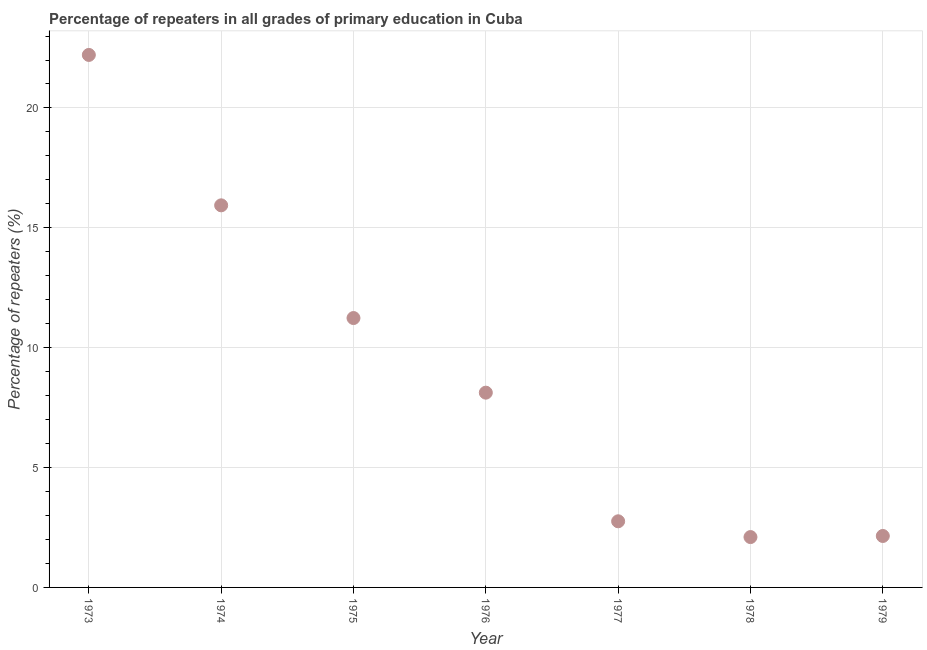What is the percentage of repeaters in primary education in 1973?
Make the answer very short. 22.21. Across all years, what is the maximum percentage of repeaters in primary education?
Make the answer very short. 22.21. Across all years, what is the minimum percentage of repeaters in primary education?
Make the answer very short. 2.1. In which year was the percentage of repeaters in primary education maximum?
Ensure brevity in your answer.  1973. In which year was the percentage of repeaters in primary education minimum?
Offer a terse response. 1978. What is the sum of the percentage of repeaters in primary education?
Keep it short and to the point. 64.52. What is the difference between the percentage of repeaters in primary education in 1975 and 1979?
Offer a very short reply. 9.09. What is the average percentage of repeaters in primary education per year?
Your answer should be very brief. 9.22. What is the median percentage of repeaters in primary education?
Offer a very short reply. 8.12. What is the ratio of the percentage of repeaters in primary education in 1973 to that in 1979?
Offer a very short reply. 10.35. Is the difference between the percentage of repeaters in primary education in 1973 and 1977 greater than the difference between any two years?
Make the answer very short. No. What is the difference between the highest and the second highest percentage of repeaters in primary education?
Keep it short and to the point. 6.27. Is the sum of the percentage of repeaters in primary education in 1973 and 1977 greater than the maximum percentage of repeaters in primary education across all years?
Make the answer very short. Yes. What is the difference between the highest and the lowest percentage of repeaters in primary education?
Your answer should be very brief. 20.11. Does the percentage of repeaters in primary education monotonically increase over the years?
Provide a short and direct response. No. How many dotlines are there?
Provide a succinct answer. 1. What is the difference between two consecutive major ticks on the Y-axis?
Ensure brevity in your answer.  5. Does the graph contain any zero values?
Offer a very short reply. No. Does the graph contain grids?
Provide a short and direct response. Yes. What is the title of the graph?
Ensure brevity in your answer.  Percentage of repeaters in all grades of primary education in Cuba. What is the label or title of the X-axis?
Make the answer very short. Year. What is the label or title of the Y-axis?
Offer a terse response. Percentage of repeaters (%). What is the Percentage of repeaters (%) in 1973?
Your answer should be very brief. 22.21. What is the Percentage of repeaters (%) in 1974?
Your response must be concise. 15.94. What is the Percentage of repeaters (%) in 1975?
Give a very brief answer. 11.24. What is the Percentage of repeaters (%) in 1976?
Your answer should be very brief. 8.12. What is the Percentage of repeaters (%) in 1977?
Keep it short and to the point. 2.76. What is the Percentage of repeaters (%) in 1978?
Ensure brevity in your answer.  2.1. What is the Percentage of repeaters (%) in 1979?
Ensure brevity in your answer.  2.15. What is the difference between the Percentage of repeaters (%) in 1973 and 1974?
Your answer should be compact. 6.27. What is the difference between the Percentage of repeaters (%) in 1973 and 1975?
Offer a terse response. 10.98. What is the difference between the Percentage of repeaters (%) in 1973 and 1976?
Offer a terse response. 14.09. What is the difference between the Percentage of repeaters (%) in 1973 and 1977?
Provide a succinct answer. 19.45. What is the difference between the Percentage of repeaters (%) in 1973 and 1978?
Keep it short and to the point. 20.11. What is the difference between the Percentage of repeaters (%) in 1973 and 1979?
Ensure brevity in your answer.  20.07. What is the difference between the Percentage of repeaters (%) in 1974 and 1975?
Give a very brief answer. 4.7. What is the difference between the Percentage of repeaters (%) in 1974 and 1976?
Offer a very short reply. 7.81. What is the difference between the Percentage of repeaters (%) in 1974 and 1977?
Make the answer very short. 13.18. What is the difference between the Percentage of repeaters (%) in 1974 and 1978?
Your answer should be compact. 13.84. What is the difference between the Percentage of repeaters (%) in 1974 and 1979?
Offer a terse response. 13.79. What is the difference between the Percentage of repeaters (%) in 1975 and 1976?
Ensure brevity in your answer.  3.11. What is the difference between the Percentage of repeaters (%) in 1975 and 1977?
Your answer should be compact. 8.48. What is the difference between the Percentage of repeaters (%) in 1975 and 1978?
Make the answer very short. 9.14. What is the difference between the Percentage of repeaters (%) in 1975 and 1979?
Ensure brevity in your answer.  9.09. What is the difference between the Percentage of repeaters (%) in 1976 and 1977?
Offer a terse response. 5.37. What is the difference between the Percentage of repeaters (%) in 1976 and 1978?
Keep it short and to the point. 6.02. What is the difference between the Percentage of repeaters (%) in 1976 and 1979?
Your response must be concise. 5.98. What is the difference between the Percentage of repeaters (%) in 1977 and 1978?
Your response must be concise. 0.66. What is the difference between the Percentage of repeaters (%) in 1977 and 1979?
Provide a succinct answer. 0.61. What is the difference between the Percentage of repeaters (%) in 1978 and 1979?
Ensure brevity in your answer.  -0.05. What is the ratio of the Percentage of repeaters (%) in 1973 to that in 1974?
Your answer should be very brief. 1.39. What is the ratio of the Percentage of repeaters (%) in 1973 to that in 1975?
Your response must be concise. 1.98. What is the ratio of the Percentage of repeaters (%) in 1973 to that in 1976?
Make the answer very short. 2.73. What is the ratio of the Percentage of repeaters (%) in 1973 to that in 1977?
Provide a succinct answer. 8.05. What is the ratio of the Percentage of repeaters (%) in 1973 to that in 1978?
Keep it short and to the point. 10.57. What is the ratio of the Percentage of repeaters (%) in 1973 to that in 1979?
Offer a terse response. 10.35. What is the ratio of the Percentage of repeaters (%) in 1974 to that in 1975?
Keep it short and to the point. 1.42. What is the ratio of the Percentage of repeaters (%) in 1974 to that in 1976?
Provide a succinct answer. 1.96. What is the ratio of the Percentage of repeaters (%) in 1974 to that in 1977?
Give a very brief answer. 5.78. What is the ratio of the Percentage of repeaters (%) in 1974 to that in 1978?
Your answer should be compact. 7.59. What is the ratio of the Percentage of repeaters (%) in 1974 to that in 1979?
Make the answer very short. 7.43. What is the ratio of the Percentage of repeaters (%) in 1975 to that in 1976?
Offer a very short reply. 1.38. What is the ratio of the Percentage of repeaters (%) in 1975 to that in 1977?
Offer a very short reply. 4.07. What is the ratio of the Percentage of repeaters (%) in 1975 to that in 1978?
Your answer should be very brief. 5.35. What is the ratio of the Percentage of repeaters (%) in 1975 to that in 1979?
Provide a succinct answer. 5.24. What is the ratio of the Percentage of repeaters (%) in 1976 to that in 1977?
Your answer should be very brief. 2.94. What is the ratio of the Percentage of repeaters (%) in 1976 to that in 1978?
Ensure brevity in your answer.  3.87. What is the ratio of the Percentage of repeaters (%) in 1976 to that in 1979?
Keep it short and to the point. 3.79. What is the ratio of the Percentage of repeaters (%) in 1977 to that in 1978?
Give a very brief answer. 1.31. What is the ratio of the Percentage of repeaters (%) in 1977 to that in 1979?
Give a very brief answer. 1.28. What is the ratio of the Percentage of repeaters (%) in 1978 to that in 1979?
Your answer should be very brief. 0.98. 